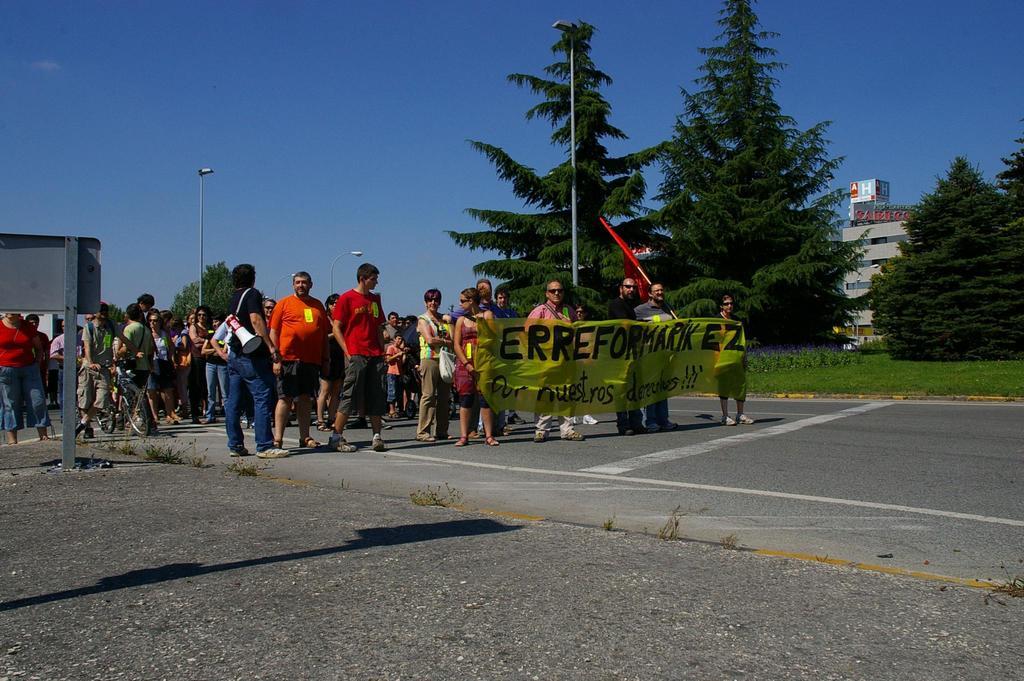What are these people walking for?
Offer a terse response. Unanswerable. 